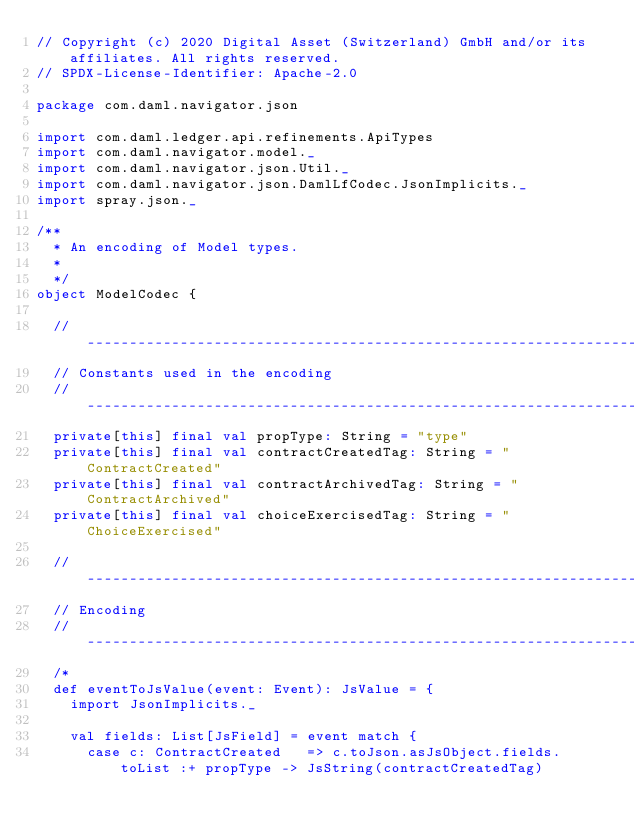<code> <loc_0><loc_0><loc_500><loc_500><_Scala_>// Copyright (c) 2020 Digital Asset (Switzerland) GmbH and/or its affiliates. All rights reserved.
// SPDX-License-Identifier: Apache-2.0

package com.daml.navigator.json

import com.daml.ledger.api.refinements.ApiTypes
import com.daml.navigator.model._
import com.daml.navigator.json.Util._
import com.daml.navigator.json.DamlLfCodec.JsonImplicits._
import spray.json._

/**
  * An encoding of Model types.
  *
  */
object ModelCodec {

  // ------------------------------------------------------------------------------------------------------------------
  // Constants used in the encoding
  // ------------------------------------------------------------------------------------------------------------------
  private[this] final val propType: String = "type"
  private[this] final val contractCreatedTag: String = "ContractCreated"
  private[this] final val contractArchivedTag: String = "ContractArchived"
  private[this] final val choiceExercisedTag: String = "ChoiceExercised"

  // ------------------------------------------------------------------------------------------------------------------
  // Encoding
  // ------------------------------------------------------------------------------------------------------------------
  /*
  def eventToJsValue(event: Event): JsValue = {
    import JsonImplicits._

    val fields: List[JsField] = event match {
      case c: ContractCreated   => c.toJson.asJsObject.fields.toList :+ propType -> JsString(contractCreatedTag)</code> 